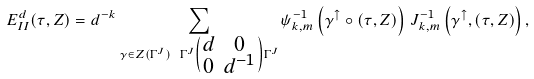<formula> <loc_0><loc_0><loc_500><loc_500>E _ { I I } ^ { d } ( \tau , Z ) = d ^ { - k } \sum _ { \gamma \in Z ( \Gamma ^ { J } ) \ \Gamma ^ { J } \left ( \begin{smallmatrix} d & 0 \\ 0 & d ^ { - 1 } \end{smallmatrix} \right ) \Gamma ^ { J } } \psi _ { k , m } ^ { - 1 } \left ( \gamma ^ { \uparrow } \circ ( \tau , Z ) \right ) \, J _ { k , m } ^ { - 1 } \left ( \gamma ^ { \uparrow } , ( \tau , Z ) \right ) ,</formula> 